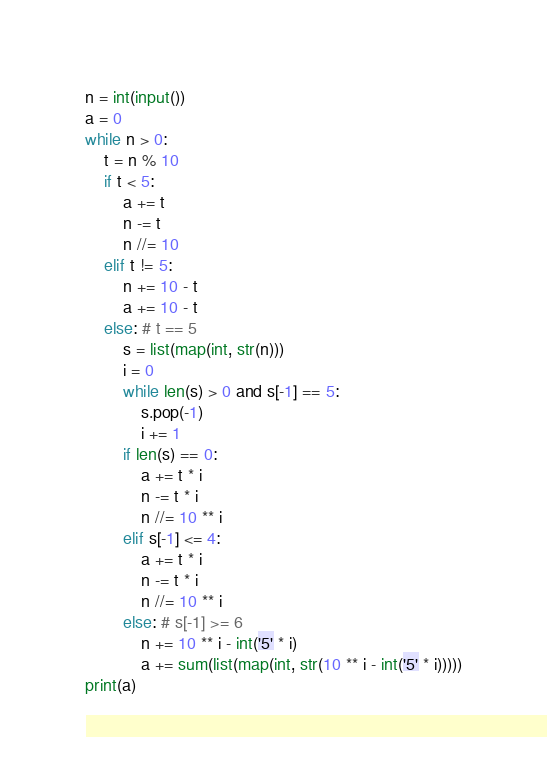<code> <loc_0><loc_0><loc_500><loc_500><_Python_>n = int(input())
a = 0
while n > 0:
    t = n % 10
    if t < 5:
        a += t
        n -= t
        n //= 10
    elif t != 5:
        n += 10 - t
        a += 10 - t
    else: # t == 5
        s = list(map(int, str(n)))
        i = 0
        while len(s) > 0 and s[-1] == 5:
            s.pop(-1)
            i += 1
        if len(s) == 0:
            a += t * i
            n -= t * i
            n //= 10 ** i
        elif s[-1] <= 4:
            a += t * i
            n -= t * i
            n //= 10 ** i
        else: # s[-1] >= 6
            n += 10 ** i - int('5' * i)
            a += sum(list(map(int, str(10 ** i - int('5' * i)))))
print(a)</code> 